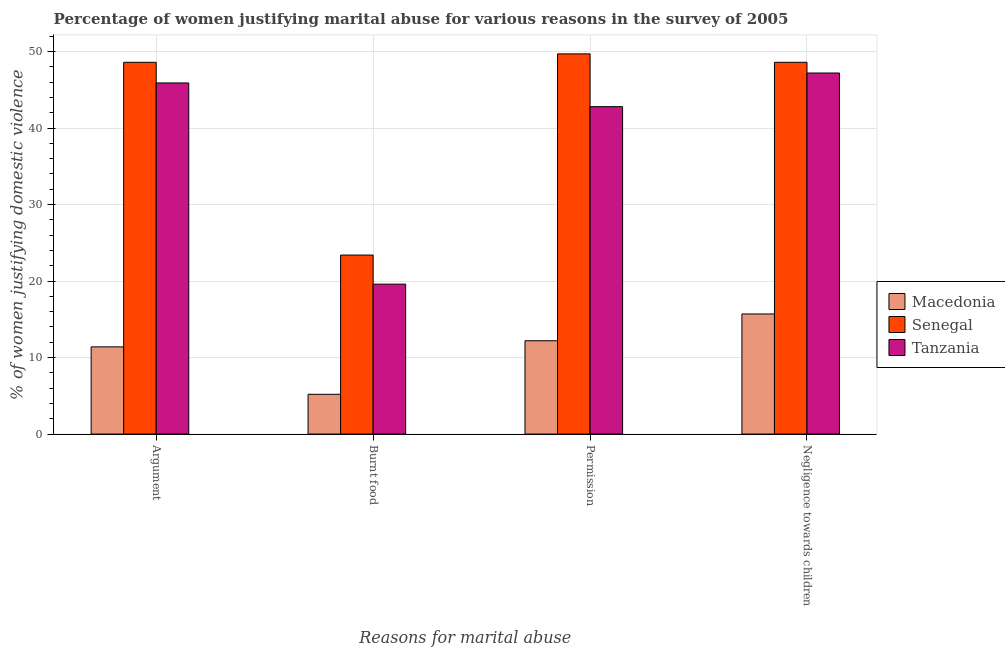How many different coloured bars are there?
Make the answer very short. 3. How many groups of bars are there?
Offer a very short reply. 4. Are the number of bars per tick equal to the number of legend labels?
Offer a terse response. Yes. How many bars are there on the 4th tick from the left?
Your answer should be compact. 3. How many bars are there on the 1st tick from the right?
Make the answer very short. 3. What is the label of the 3rd group of bars from the left?
Offer a very short reply. Permission. What is the percentage of women justifying abuse for burning food in Tanzania?
Keep it short and to the point. 19.6. Across all countries, what is the maximum percentage of women justifying abuse in the case of an argument?
Give a very brief answer. 48.6. In which country was the percentage of women justifying abuse in the case of an argument maximum?
Your response must be concise. Senegal. In which country was the percentage of women justifying abuse for burning food minimum?
Make the answer very short. Macedonia. What is the total percentage of women justifying abuse for burning food in the graph?
Your answer should be very brief. 48.2. What is the difference between the percentage of women justifying abuse for showing negligence towards children in Tanzania and that in Senegal?
Keep it short and to the point. -1.4. What is the difference between the percentage of women justifying abuse for burning food in Tanzania and the percentage of women justifying abuse in the case of an argument in Macedonia?
Keep it short and to the point. 8.2. What is the average percentage of women justifying abuse in the case of an argument per country?
Make the answer very short. 35.3. What is the difference between the percentage of women justifying abuse in the case of an argument and percentage of women justifying abuse for going without permission in Tanzania?
Provide a short and direct response. 3.1. What is the ratio of the percentage of women justifying abuse for going without permission in Tanzania to that in Senegal?
Your answer should be very brief. 0.86. Is the percentage of women justifying abuse in the case of an argument in Macedonia less than that in Senegal?
Keep it short and to the point. Yes. What is the difference between the highest and the second highest percentage of women justifying abuse in the case of an argument?
Offer a very short reply. 2.7. What is the difference between the highest and the lowest percentage of women justifying abuse for going without permission?
Ensure brevity in your answer.  37.5. What does the 1st bar from the left in Argument represents?
Offer a very short reply. Macedonia. What does the 1st bar from the right in Permission represents?
Provide a succinct answer. Tanzania. Is it the case that in every country, the sum of the percentage of women justifying abuse in the case of an argument and percentage of women justifying abuse for burning food is greater than the percentage of women justifying abuse for going without permission?
Give a very brief answer. Yes. How many countries are there in the graph?
Ensure brevity in your answer.  3. Are the values on the major ticks of Y-axis written in scientific E-notation?
Keep it short and to the point. No. Does the graph contain grids?
Provide a short and direct response. Yes. What is the title of the graph?
Ensure brevity in your answer.  Percentage of women justifying marital abuse for various reasons in the survey of 2005. What is the label or title of the X-axis?
Provide a short and direct response. Reasons for marital abuse. What is the label or title of the Y-axis?
Make the answer very short. % of women justifying domestic violence. What is the % of women justifying domestic violence of Senegal in Argument?
Your answer should be very brief. 48.6. What is the % of women justifying domestic violence in Tanzania in Argument?
Offer a very short reply. 45.9. What is the % of women justifying domestic violence in Macedonia in Burnt food?
Your response must be concise. 5.2. What is the % of women justifying domestic violence of Senegal in Burnt food?
Offer a very short reply. 23.4. What is the % of women justifying domestic violence of Tanzania in Burnt food?
Offer a very short reply. 19.6. What is the % of women justifying domestic violence in Macedonia in Permission?
Keep it short and to the point. 12.2. What is the % of women justifying domestic violence of Senegal in Permission?
Ensure brevity in your answer.  49.7. What is the % of women justifying domestic violence of Tanzania in Permission?
Offer a very short reply. 42.8. What is the % of women justifying domestic violence in Senegal in Negligence towards children?
Give a very brief answer. 48.6. What is the % of women justifying domestic violence of Tanzania in Negligence towards children?
Offer a very short reply. 47.2. Across all Reasons for marital abuse, what is the maximum % of women justifying domestic violence of Senegal?
Make the answer very short. 49.7. Across all Reasons for marital abuse, what is the maximum % of women justifying domestic violence of Tanzania?
Offer a very short reply. 47.2. Across all Reasons for marital abuse, what is the minimum % of women justifying domestic violence in Senegal?
Your answer should be very brief. 23.4. Across all Reasons for marital abuse, what is the minimum % of women justifying domestic violence of Tanzania?
Give a very brief answer. 19.6. What is the total % of women justifying domestic violence of Macedonia in the graph?
Give a very brief answer. 44.5. What is the total % of women justifying domestic violence of Senegal in the graph?
Offer a terse response. 170.3. What is the total % of women justifying domestic violence of Tanzania in the graph?
Ensure brevity in your answer.  155.5. What is the difference between the % of women justifying domestic violence in Senegal in Argument and that in Burnt food?
Give a very brief answer. 25.2. What is the difference between the % of women justifying domestic violence of Tanzania in Argument and that in Burnt food?
Provide a short and direct response. 26.3. What is the difference between the % of women justifying domestic violence in Macedonia in Argument and that in Permission?
Offer a terse response. -0.8. What is the difference between the % of women justifying domestic violence in Senegal in Argument and that in Permission?
Provide a succinct answer. -1.1. What is the difference between the % of women justifying domestic violence in Tanzania in Argument and that in Permission?
Your response must be concise. 3.1. What is the difference between the % of women justifying domestic violence in Senegal in Argument and that in Negligence towards children?
Keep it short and to the point. 0. What is the difference between the % of women justifying domestic violence of Macedonia in Burnt food and that in Permission?
Your response must be concise. -7. What is the difference between the % of women justifying domestic violence in Senegal in Burnt food and that in Permission?
Your answer should be very brief. -26.3. What is the difference between the % of women justifying domestic violence of Tanzania in Burnt food and that in Permission?
Ensure brevity in your answer.  -23.2. What is the difference between the % of women justifying domestic violence of Macedonia in Burnt food and that in Negligence towards children?
Offer a terse response. -10.5. What is the difference between the % of women justifying domestic violence of Senegal in Burnt food and that in Negligence towards children?
Offer a terse response. -25.2. What is the difference between the % of women justifying domestic violence in Tanzania in Burnt food and that in Negligence towards children?
Keep it short and to the point. -27.6. What is the difference between the % of women justifying domestic violence in Tanzania in Permission and that in Negligence towards children?
Make the answer very short. -4.4. What is the difference between the % of women justifying domestic violence of Macedonia in Argument and the % of women justifying domestic violence of Senegal in Burnt food?
Your response must be concise. -12. What is the difference between the % of women justifying domestic violence of Macedonia in Argument and the % of women justifying domestic violence of Tanzania in Burnt food?
Give a very brief answer. -8.2. What is the difference between the % of women justifying domestic violence in Macedonia in Argument and the % of women justifying domestic violence in Senegal in Permission?
Make the answer very short. -38.3. What is the difference between the % of women justifying domestic violence of Macedonia in Argument and the % of women justifying domestic violence of Tanzania in Permission?
Offer a very short reply. -31.4. What is the difference between the % of women justifying domestic violence in Senegal in Argument and the % of women justifying domestic violence in Tanzania in Permission?
Keep it short and to the point. 5.8. What is the difference between the % of women justifying domestic violence in Macedonia in Argument and the % of women justifying domestic violence in Senegal in Negligence towards children?
Ensure brevity in your answer.  -37.2. What is the difference between the % of women justifying domestic violence of Macedonia in Argument and the % of women justifying domestic violence of Tanzania in Negligence towards children?
Give a very brief answer. -35.8. What is the difference between the % of women justifying domestic violence in Senegal in Argument and the % of women justifying domestic violence in Tanzania in Negligence towards children?
Offer a terse response. 1.4. What is the difference between the % of women justifying domestic violence in Macedonia in Burnt food and the % of women justifying domestic violence in Senegal in Permission?
Your answer should be compact. -44.5. What is the difference between the % of women justifying domestic violence of Macedonia in Burnt food and the % of women justifying domestic violence of Tanzania in Permission?
Your answer should be very brief. -37.6. What is the difference between the % of women justifying domestic violence of Senegal in Burnt food and the % of women justifying domestic violence of Tanzania in Permission?
Ensure brevity in your answer.  -19.4. What is the difference between the % of women justifying domestic violence in Macedonia in Burnt food and the % of women justifying domestic violence in Senegal in Negligence towards children?
Offer a very short reply. -43.4. What is the difference between the % of women justifying domestic violence in Macedonia in Burnt food and the % of women justifying domestic violence in Tanzania in Negligence towards children?
Make the answer very short. -42. What is the difference between the % of women justifying domestic violence in Senegal in Burnt food and the % of women justifying domestic violence in Tanzania in Negligence towards children?
Your answer should be very brief. -23.8. What is the difference between the % of women justifying domestic violence in Macedonia in Permission and the % of women justifying domestic violence in Senegal in Negligence towards children?
Make the answer very short. -36.4. What is the difference between the % of women justifying domestic violence in Macedonia in Permission and the % of women justifying domestic violence in Tanzania in Negligence towards children?
Ensure brevity in your answer.  -35. What is the difference between the % of women justifying domestic violence of Senegal in Permission and the % of women justifying domestic violence of Tanzania in Negligence towards children?
Provide a short and direct response. 2.5. What is the average % of women justifying domestic violence in Macedonia per Reasons for marital abuse?
Your response must be concise. 11.12. What is the average % of women justifying domestic violence of Senegal per Reasons for marital abuse?
Your answer should be compact. 42.58. What is the average % of women justifying domestic violence of Tanzania per Reasons for marital abuse?
Offer a terse response. 38.88. What is the difference between the % of women justifying domestic violence in Macedonia and % of women justifying domestic violence in Senegal in Argument?
Your answer should be very brief. -37.2. What is the difference between the % of women justifying domestic violence of Macedonia and % of women justifying domestic violence of Tanzania in Argument?
Ensure brevity in your answer.  -34.5. What is the difference between the % of women justifying domestic violence of Macedonia and % of women justifying domestic violence of Senegal in Burnt food?
Your response must be concise. -18.2. What is the difference between the % of women justifying domestic violence of Macedonia and % of women justifying domestic violence of Tanzania in Burnt food?
Provide a succinct answer. -14.4. What is the difference between the % of women justifying domestic violence of Macedonia and % of women justifying domestic violence of Senegal in Permission?
Ensure brevity in your answer.  -37.5. What is the difference between the % of women justifying domestic violence of Macedonia and % of women justifying domestic violence of Tanzania in Permission?
Make the answer very short. -30.6. What is the difference between the % of women justifying domestic violence of Senegal and % of women justifying domestic violence of Tanzania in Permission?
Your response must be concise. 6.9. What is the difference between the % of women justifying domestic violence of Macedonia and % of women justifying domestic violence of Senegal in Negligence towards children?
Offer a terse response. -32.9. What is the difference between the % of women justifying domestic violence of Macedonia and % of women justifying domestic violence of Tanzania in Negligence towards children?
Your response must be concise. -31.5. What is the ratio of the % of women justifying domestic violence of Macedonia in Argument to that in Burnt food?
Your response must be concise. 2.19. What is the ratio of the % of women justifying domestic violence of Senegal in Argument to that in Burnt food?
Your answer should be compact. 2.08. What is the ratio of the % of women justifying domestic violence of Tanzania in Argument to that in Burnt food?
Make the answer very short. 2.34. What is the ratio of the % of women justifying domestic violence of Macedonia in Argument to that in Permission?
Provide a short and direct response. 0.93. What is the ratio of the % of women justifying domestic violence in Senegal in Argument to that in Permission?
Provide a succinct answer. 0.98. What is the ratio of the % of women justifying domestic violence in Tanzania in Argument to that in Permission?
Make the answer very short. 1.07. What is the ratio of the % of women justifying domestic violence in Macedonia in Argument to that in Negligence towards children?
Provide a short and direct response. 0.73. What is the ratio of the % of women justifying domestic violence of Tanzania in Argument to that in Negligence towards children?
Provide a succinct answer. 0.97. What is the ratio of the % of women justifying domestic violence in Macedonia in Burnt food to that in Permission?
Give a very brief answer. 0.43. What is the ratio of the % of women justifying domestic violence in Senegal in Burnt food to that in Permission?
Provide a short and direct response. 0.47. What is the ratio of the % of women justifying domestic violence in Tanzania in Burnt food to that in Permission?
Provide a short and direct response. 0.46. What is the ratio of the % of women justifying domestic violence of Macedonia in Burnt food to that in Negligence towards children?
Make the answer very short. 0.33. What is the ratio of the % of women justifying domestic violence in Senegal in Burnt food to that in Negligence towards children?
Ensure brevity in your answer.  0.48. What is the ratio of the % of women justifying domestic violence of Tanzania in Burnt food to that in Negligence towards children?
Your answer should be compact. 0.42. What is the ratio of the % of women justifying domestic violence in Macedonia in Permission to that in Negligence towards children?
Keep it short and to the point. 0.78. What is the ratio of the % of women justifying domestic violence of Senegal in Permission to that in Negligence towards children?
Provide a succinct answer. 1.02. What is the ratio of the % of women justifying domestic violence in Tanzania in Permission to that in Negligence towards children?
Provide a succinct answer. 0.91. What is the difference between the highest and the second highest % of women justifying domestic violence of Macedonia?
Keep it short and to the point. 3.5. What is the difference between the highest and the lowest % of women justifying domestic violence in Senegal?
Offer a terse response. 26.3. What is the difference between the highest and the lowest % of women justifying domestic violence in Tanzania?
Provide a succinct answer. 27.6. 